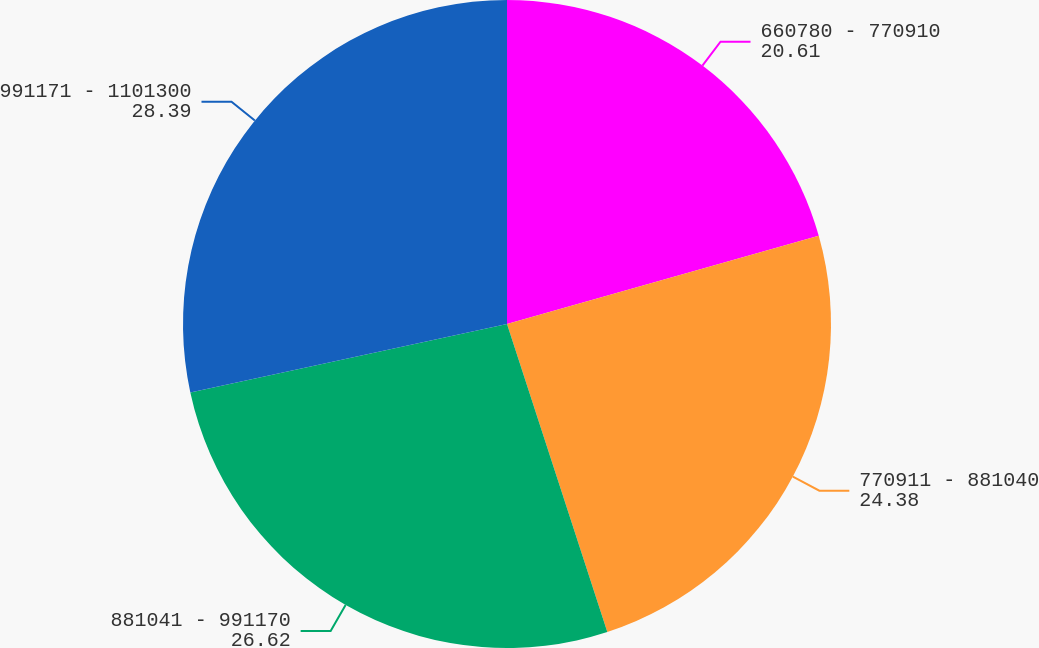<chart> <loc_0><loc_0><loc_500><loc_500><pie_chart><fcel>660780 - 770910<fcel>770911 - 881040<fcel>881041 - 991170<fcel>991171 - 1101300<nl><fcel>20.61%<fcel>24.38%<fcel>26.62%<fcel>28.39%<nl></chart> 